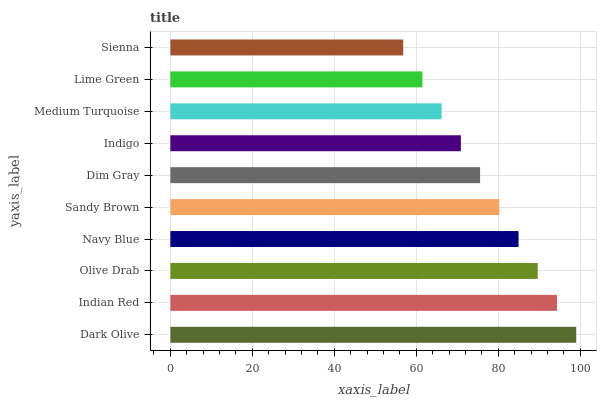Is Sienna the minimum?
Answer yes or no. Yes. Is Dark Olive the maximum?
Answer yes or no. Yes. Is Indian Red the minimum?
Answer yes or no. No. Is Indian Red the maximum?
Answer yes or no. No. Is Dark Olive greater than Indian Red?
Answer yes or no. Yes. Is Indian Red less than Dark Olive?
Answer yes or no. Yes. Is Indian Red greater than Dark Olive?
Answer yes or no. No. Is Dark Olive less than Indian Red?
Answer yes or no. No. Is Sandy Brown the high median?
Answer yes or no. Yes. Is Dim Gray the low median?
Answer yes or no. Yes. Is Indian Red the high median?
Answer yes or no. No. Is Indian Red the low median?
Answer yes or no. No. 